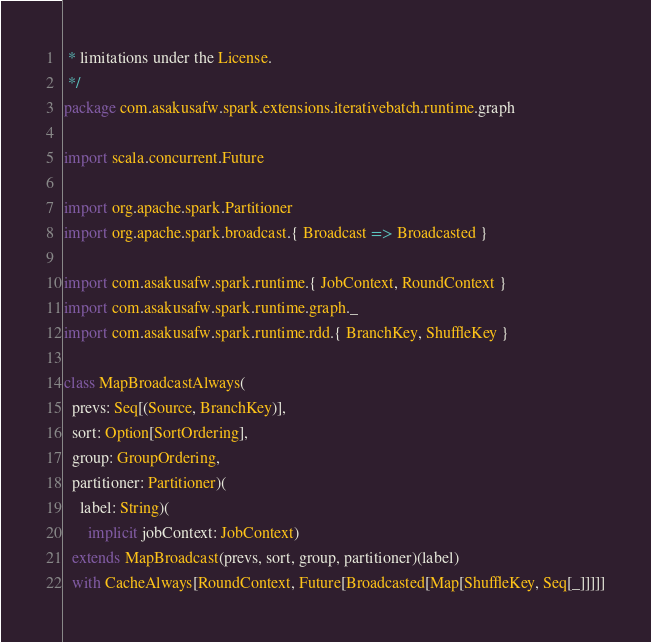<code> <loc_0><loc_0><loc_500><loc_500><_Scala_> * limitations under the License.
 */
package com.asakusafw.spark.extensions.iterativebatch.runtime.graph

import scala.concurrent.Future

import org.apache.spark.Partitioner
import org.apache.spark.broadcast.{ Broadcast => Broadcasted }

import com.asakusafw.spark.runtime.{ JobContext, RoundContext }
import com.asakusafw.spark.runtime.graph._
import com.asakusafw.spark.runtime.rdd.{ BranchKey, ShuffleKey }

class MapBroadcastAlways(
  prevs: Seq[(Source, BranchKey)],
  sort: Option[SortOrdering],
  group: GroupOrdering,
  partitioner: Partitioner)(
    label: String)(
      implicit jobContext: JobContext)
  extends MapBroadcast(prevs, sort, group, partitioner)(label)
  with CacheAlways[RoundContext, Future[Broadcasted[Map[ShuffleKey, Seq[_]]]]]
</code> 